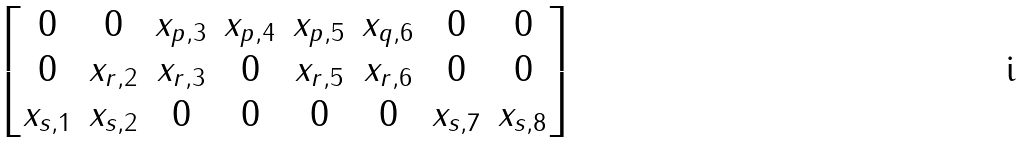<formula> <loc_0><loc_0><loc_500><loc_500>\begin{bmatrix} 0 & 0 & x _ { p , 3 } & x _ { p , 4 } & x _ { p , 5 } & x _ { q , 6 } & 0 & 0 \\ 0 & x _ { r , 2 } & x _ { r , 3 } & 0 & x _ { r , 5 } & x _ { r , 6 } & 0 & 0 \\ x _ { s , 1 } & x _ { s , 2 } & 0 & 0 & 0 & 0 & x _ { s , 7 } & x _ { s , 8 } \end{bmatrix}</formula> 